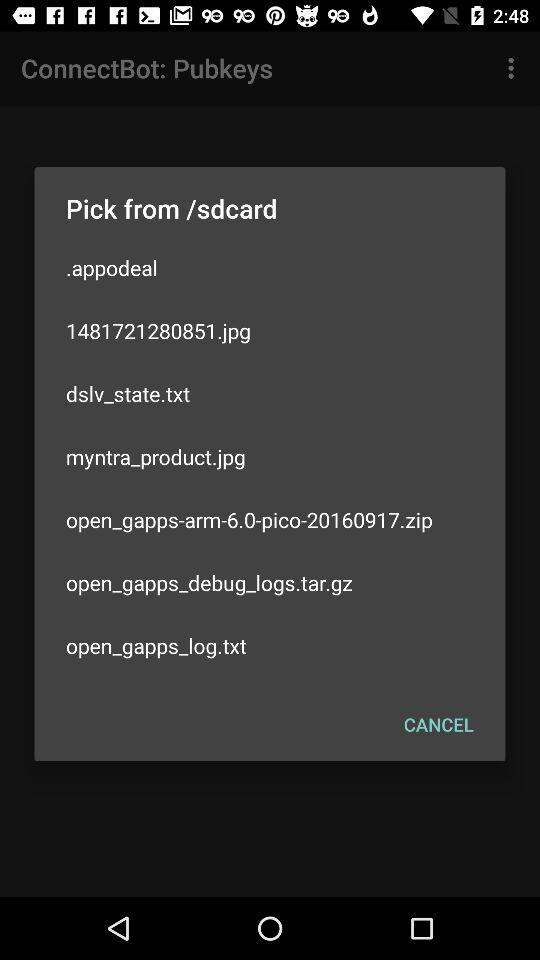What is the name of the zip file? The name of the zip file is "open_gapps-arm-6.0-pico-20160917.zip". 